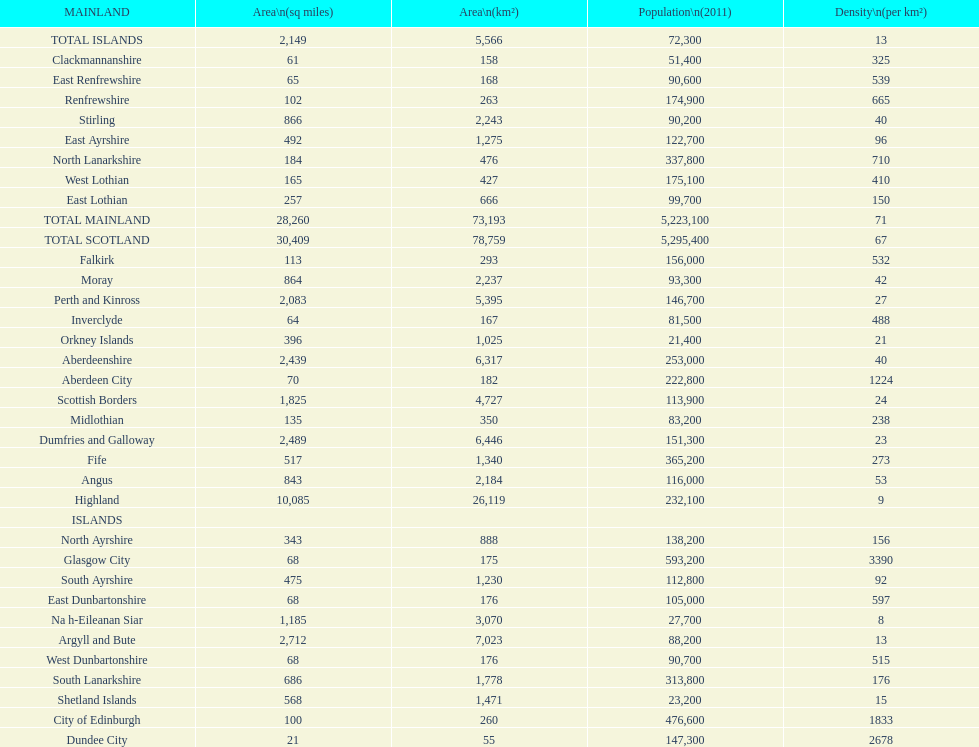What is the difference in square miles from angus and fife? 326. 